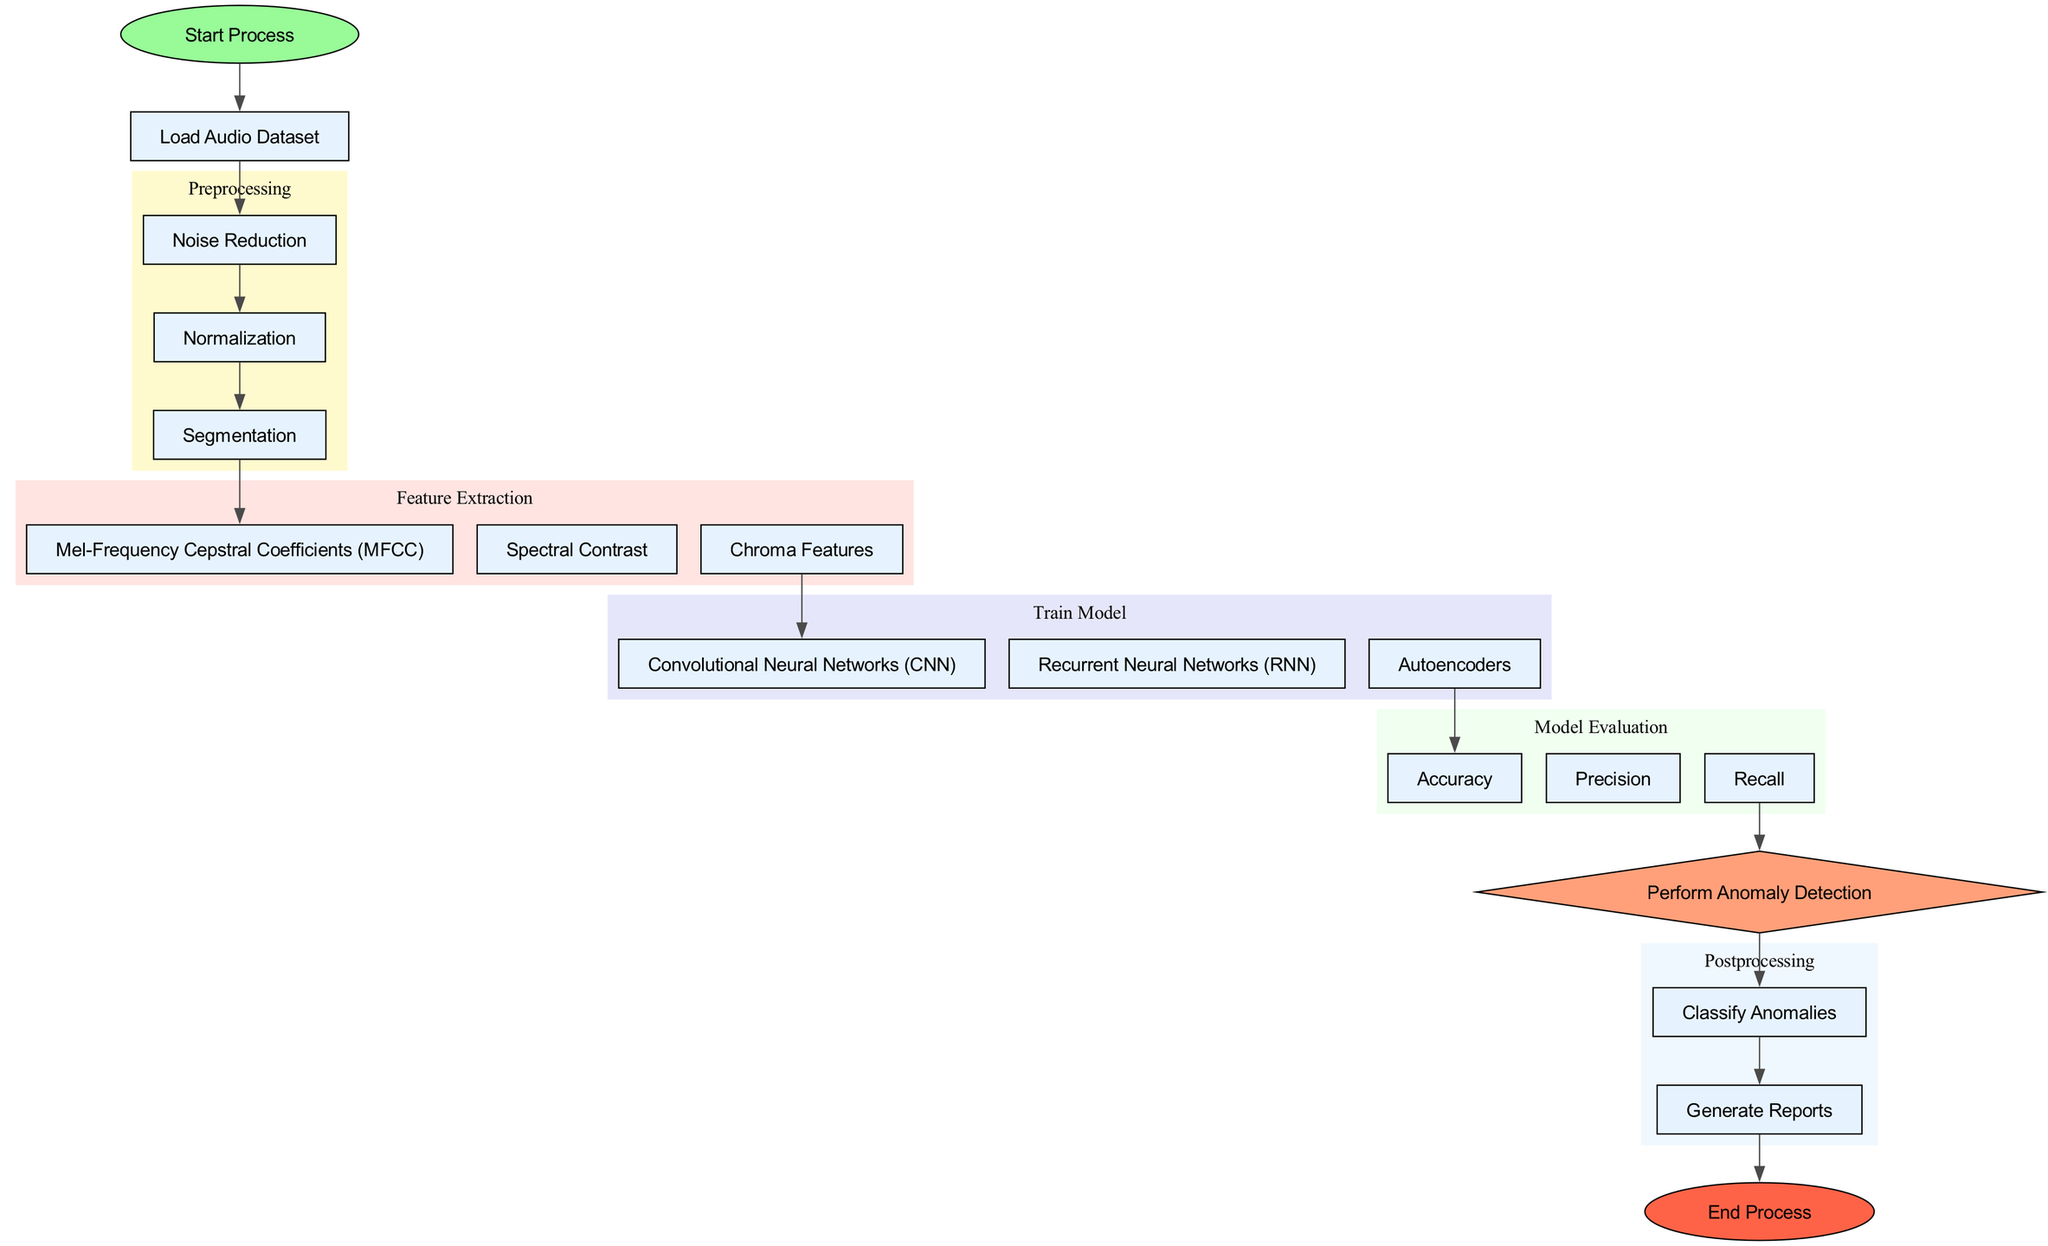What is the first step in the process? The flowchart begins with the "Start Process" node, which is the entry point of the entire diagram.
Answer: Start Process How many preprocessing steps are there? The preprocessing phase has three defined steps: Noise Reduction, Normalization, and Segmentation. Therefore, there are three preprocessing steps.
Answer: 3 Which step comes after Segmentation? After Segmentation, the diagram shows a direct line to the first audio feature extraction method, which is Mel-Frequency Cepstral Coefficients (MFCC).
Answer: Mel-Frequency Cepstral Coefficients (MFCC) What algorithms are used to train the model? In the diagram, there are three algorithms listed under "Train Machine Learning Model": Convolutional Neural Networks (CNN), Recurrent Neural Networks (RNN), and Autoencoders.
Answer: Convolutional Neural Networks, Recurrent Neural Networks, Autoencoders What metric follows Autoencoders in the evaluation phase? The flow transitions from Autoencoders to the metric "Accuracy," indicating it is the next step in the evaluation.
Answer: Accuracy How is the anomaly detection performed? The diagram illustrates that anomaly detection is directly performed after evaluating model performance, linking it with both Recall and the input from the metrics.
Answer: Perform Anomaly Detection What is the last step in the process? According to the diagram structure, after generating reports, the final node indicates "End Process," which concludes the flow.
Answer: End Process 